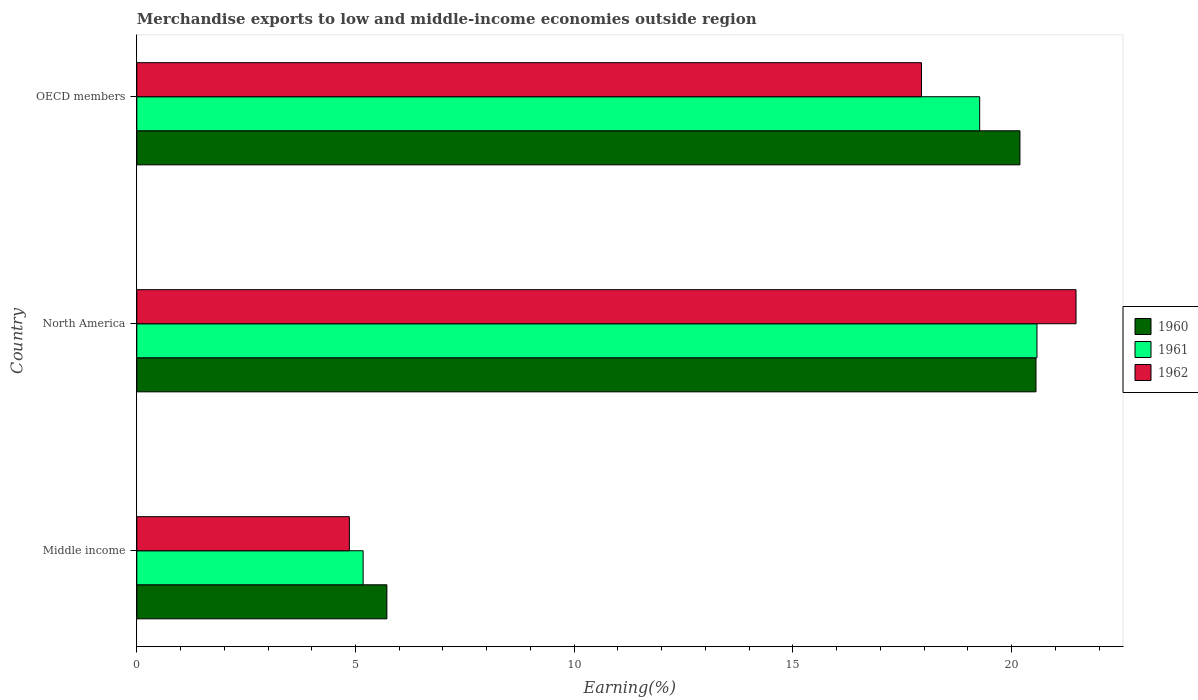How many different coloured bars are there?
Offer a very short reply. 3. Are the number of bars on each tick of the Y-axis equal?
Your response must be concise. Yes. What is the percentage of amount earned from merchandise exports in 1960 in OECD members?
Offer a terse response. 20.19. Across all countries, what is the maximum percentage of amount earned from merchandise exports in 1961?
Your answer should be very brief. 20.58. Across all countries, what is the minimum percentage of amount earned from merchandise exports in 1960?
Your answer should be compact. 5.72. In which country was the percentage of amount earned from merchandise exports in 1962 minimum?
Provide a short and direct response. Middle income. What is the total percentage of amount earned from merchandise exports in 1960 in the graph?
Keep it short and to the point. 46.47. What is the difference between the percentage of amount earned from merchandise exports in 1960 in Middle income and that in North America?
Your response must be concise. -14.84. What is the difference between the percentage of amount earned from merchandise exports in 1961 in Middle income and the percentage of amount earned from merchandise exports in 1960 in North America?
Your response must be concise. -15.38. What is the average percentage of amount earned from merchandise exports in 1962 per country?
Provide a succinct answer. 14.76. What is the difference between the percentage of amount earned from merchandise exports in 1960 and percentage of amount earned from merchandise exports in 1962 in OECD members?
Your answer should be very brief. 2.25. In how many countries, is the percentage of amount earned from merchandise exports in 1962 greater than 14 %?
Ensure brevity in your answer.  2. What is the ratio of the percentage of amount earned from merchandise exports in 1961 in North America to that in OECD members?
Your answer should be very brief. 1.07. What is the difference between the highest and the second highest percentage of amount earned from merchandise exports in 1962?
Offer a very short reply. 3.53. What is the difference between the highest and the lowest percentage of amount earned from merchandise exports in 1961?
Provide a succinct answer. 15.41. What does the 3rd bar from the top in North America represents?
Ensure brevity in your answer.  1960. Are all the bars in the graph horizontal?
Provide a succinct answer. Yes. How many countries are there in the graph?
Provide a succinct answer. 3. Does the graph contain grids?
Make the answer very short. No. How are the legend labels stacked?
Provide a short and direct response. Vertical. What is the title of the graph?
Provide a succinct answer. Merchandise exports to low and middle-income economies outside region. What is the label or title of the X-axis?
Provide a succinct answer. Earning(%). What is the Earning(%) in 1960 in Middle income?
Your answer should be compact. 5.72. What is the Earning(%) in 1961 in Middle income?
Offer a very short reply. 5.17. What is the Earning(%) in 1962 in Middle income?
Make the answer very short. 4.86. What is the Earning(%) of 1960 in North America?
Ensure brevity in your answer.  20.56. What is the Earning(%) of 1961 in North America?
Keep it short and to the point. 20.58. What is the Earning(%) in 1962 in North America?
Provide a succinct answer. 21.47. What is the Earning(%) of 1960 in OECD members?
Offer a very short reply. 20.19. What is the Earning(%) in 1961 in OECD members?
Your answer should be compact. 19.27. What is the Earning(%) in 1962 in OECD members?
Your answer should be very brief. 17.94. Across all countries, what is the maximum Earning(%) of 1960?
Ensure brevity in your answer.  20.56. Across all countries, what is the maximum Earning(%) of 1961?
Keep it short and to the point. 20.58. Across all countries, what is the maximum Earning(%) in 1962?
Provide a short and direct response. 21.47. Across all countries, what is the minimum Earning(%) in 1960?
Provide a short and direct response. 5.72. Across all countries, what is the minimum Earning(%) in 1961?
Provide a succinct answer. 5.17. Across all countries, what is the minimum Earning(%) of 1962?
Keep it short and to the point. 4.86. What is the total Earning(%) in 1960 in the graph?
Your response must be concise. 46.47. What is the total Earning(%) in 1961 in the graph?
Your response must be concise. 45.03. What is the total Earning(%) in 1962 in the graph?
Keep it short and to the point. 44.27. What is the difference between the Earning(%) of 1960 in Middle income and that in North America?
Ensure brevity in your answer.  -14.84. What is the difference between the Earning(%) of 1961 in Middle income and that in North America?
Offer a terse response. -15.41. What is the difference between the Earning(%) in 1962 in Middle income and that in North America?
Your answer should be compact. -16.61. What is the difference between the Earning(%) in 1960 in Middle income and that in OECD members?
Your answer should be compact. -14.47. What is the difference between the Earning(%) in 1961 in Middle income and that in OECD members?
Make the answer very short. -14.1. What is the difference between the Earning(%) in 1962 in Middle income and that in OECD members?
Provide a succinct answer. -13.08. What is the difference between the Earning(%) in 1960 in North America and that in OECD members?
Make the answer very short. 0.37. What is the difference between the Earning(%) of 1961 in North America and that in OECD members?
Provide a succinct answer. 1.31. What is the difference between the Earning(%) in 1962 in North America and that in OECD members?
Offer a terse response. 3.53. What is the difference between the Earning(%) of 1960 in Middle income and the Earning(%) of 1961 in North America?
Offer a terse response. -14.86. What is the difference between the Earning(%) of 1960 in Middle income and the Earning(%) of 1962 in North America?
Provide a succinct answer. -15.76. What is the difference between the Earning(%) in 1961 in Middle income and the Earning(%) in 1962 in North America?
Offer a very short reply. -16.3. What is the difference between the Earning(%) of 1960 in Middle income and the Earning(%) of 1961 in OECD members?
Your answer should be very brief. -13.55. What is the difference between the Earning(%) of 1960 in Middle income and the Earning(%) of 1962 in OECD members?
Provide a short and direct response. -12.22. What is the difference between the Earning(%) of 1961 in Middle income and the Earning(%) of 1962 in OECD members?
Ensure brevity in your answer.  -12.77. What is the difference between the Earning(%) of 1960 in North America and the Earning(%) of 1961 in OECD members?
Provide a short and direct response. 1.29. What is the difference between the Earning(%) of 1960 in North America and the Earning(%) of 1962 in OECD members?
Provide a succinct answer. 2.62. What is the difference between the Earning(%) in 1961 in North America and the Earning(%) in 1962 in OECD members?
Make the answer very short. 2.64. What is the average Earning(%) of 1960 per country?
Keep it short and to the point. 15.49. What is the average Earning(%) of 1961 per country?
Make the answer very short. 15.01. What is the average Earning(%) in 1962 per country?
Your answer should be compact. 14.76. What is the difference between the Earning(%) in 1960 and Earning(%) in 1961 in Middle income?
Make the answer very short. 0.54. What is the difference between the Earning(%) of 1960 and Earning(%) of 1962 in Middle income?
Your response must be concise. 0.86. What is the difference between the Earning(%) in 1961 and Earning(%) in 1962 in Middle income?
Provide a succinct answer. 0.31. What is the difference between the Earning(%) in 1960 and Earning(%) in 1961 in North America?
Your answer should be very brief. -0.02. What is the difference between the Earning(%) of 1960 and Earning(%) of 1962 in North America?
Ensure brevity in your answer.  -0.92. What is the difference between the Earning(%) in 1961 and Earning(%) in 1962 in North America?
Your answer should be very brief. -0.89. What is the difference between the Earning(%) of 1960 and Earning(%) of 1961 in OECD members?
Your response must be concise. 0.92. What is the difference between the Earning(%) of 1960 and Earning(%) of 1962 in OECD members?
Provide a short and direct response. 2.25. What is the difference between the Earning(%) of 1961 and Earning(%) of 1962 in OECD members?
Offer a very short reply. 1.33. What is the ratio of the Earning(%) of 1960 in Middle income to that in North America?
Make the answer very short. 0.28. What is the ratio of the Earning(%) in 1961 in Middle income to that in North America?
Keep it short and to the point. 0.25. What is the ratio of the Earning(%) of 1962 in Middle income to that in North America?
Keep it short and to the point. 0.23. What is the ratio of the Earning(%) of 1960 in Middle income to that in OECD members?
Make the answer very short. 0.28. What is the ratio of the Earning(%) in 1961 in Middle income to that in OECD members?
Your response must be concise. 0.27. What is the ratio of the Earning(%) in 1962 in Middle income to that in OECD members?
Provide a short and direct response. 0.27. What is the ratio of the Earning(%) in 1960 in North America to that in OECD members?
Offer a very short reply. 1.02. What is the ratio of the Earning(%) in 1961 in North America to that in OECD members?
Offer a terse response. 1.07. What is the ratio of the Earning(%) in 1962 in North America to that in OECD members?
Give a very brief answer. 1.2. What is the difference between the highest and the second highest Earning(%) in 1960?
Ensure brevity in your answer.  0.37. What is the difference between the highest and the second highest Earning(%) in 1961?
Provide a short and direct response. 1.31. What is the difference between the highest and the second highest Earning(%) in 1962?
Ensure brevity in your answer.  3.53. What is the difference between the highest and the lowest Earning(%) of 1960?
Give a very brief answer. 14.84. What is the difference between the highest and the lowest Earning(%) in 1961?
Give a very brief answer. 15.41. What is the difference between the highest and the lowest Earning(%) in 1962?
Provide a succinct answer. 16.61. 